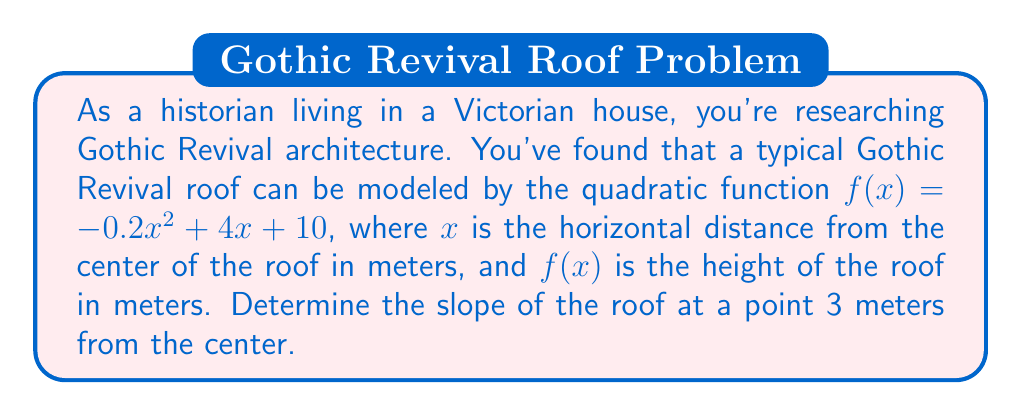Solve this math problem. To find the slope of the roof at a specific point, we need to calculate the derivative of the quadratic function and evaluate it at the given point. Here's how we can do this:

1) The quadratic function is given as:
   $$f(x) = -0.2x^2 + 4x + 10$$

2) The derivative of a quadratic function $ax^2 + bx + c$ is $2ax + b$. So, the derivative of our function is:
   $$f'(x) = -0.4x + 4$$

3) This derivative function $f'(x)$ represents the slope of the roof at any given point $x$.

4) We're asked to find the slope at a point 3 meters from the center. So, we need to evaluate $f'(3)$:

   $$f'(3) = -0.4(3) + 4$$
   $$f'(3) = -1.2 + 4 = 2.8$$

5) Therefore, the slope of the roof at a point 3 meters from the center is 2.8.

Note: In the context of roofs, this slope can be interpreted as a rise of 2.8 meters for every 1 meter of horizontal distance at that specific point.
Answer: $2.8$ 